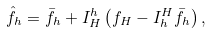Convert formula to latex. <formula><loc_0><loc_0><loc_500><loc_500>\hat { f } _ { h } = \bar { f } _ { h } + I _ { H } ^ { h } \left ( f _ { H } - I _ { h } ^ { H } \bar { f } _ { h } \right ) ,</formula> 